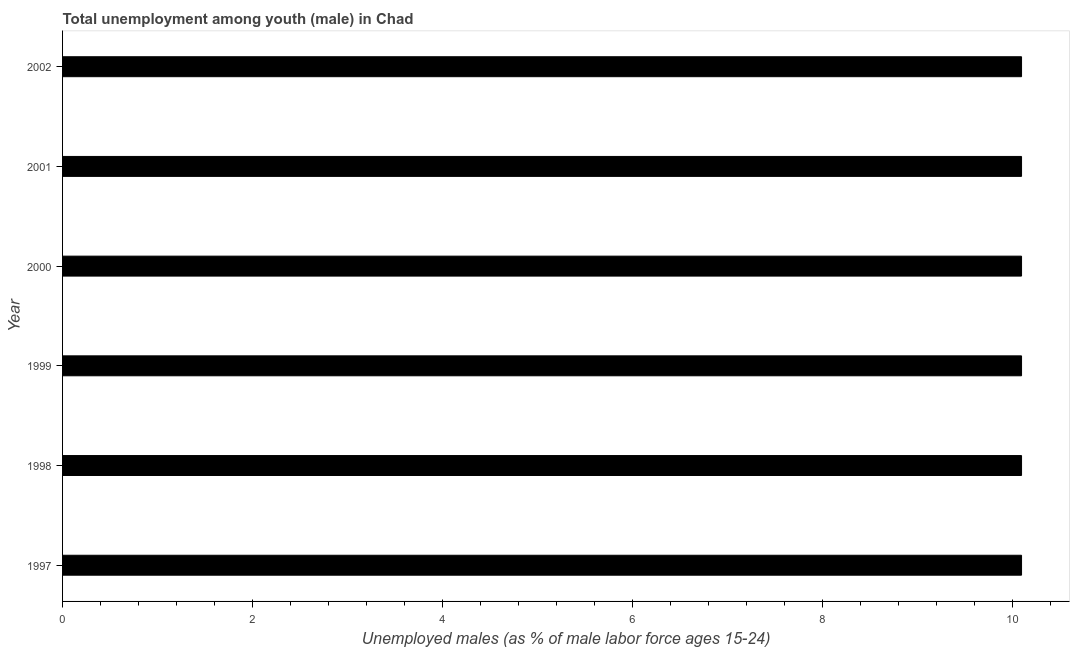Does the graph contain any zero values?
Offer a terse response. No. What is the title of the graph?
Your answer should be very brief. Total unemployment among youth (male) in Chad. What is the label or title of the X-axis?
Give a very brief answer. Unemployed males (as % of male labor force ages 15-24). What is the label or title of the Y-axis?
Keep it short and to the point. Year. What is the unemployed male youth population in 1998?
Keep it short and to the point. 10.1. Across all years, what is the maximum unemployed male youth population?
Provide a short and direct response. 10.1. Across all years, what is the minimum unemployed male youth population?
Your response must be concise. 10.1. In which year was the unemployed male youth population maximum?
Your answer should be compact. 1997. What is the sum of the unemployed male youth population?
Ensure brevity in your answer.  60.6. What is the difference between the unemployed male youth population in 1999 and 2000?
Your response must be concise. 0. What is the average unemployed male youth population per year?
Provide a succinct answer. 10.1. What is the median unemployed male youth population?
Your answer should be compact. 10.1. In how many years, is the unemployed male youth population greater than 9.2 %?
Provide a short and direct response. 6. Do a majority of the years between 2001 and 1997 (inclusive) have unemployed male youth population greater than 4.4 %?
Give a very brief answer. Yes. What is the ratio of the unemployed male youth population in 1998 to that in 1999?
Give a very brief answer. 1. Is the unemployed male youth population in 2001 less than that in 2002?
Your answer should be compact. No. Is the difference between the unemployed male youth population in 1998 and 1999 greater than the difference between any two years?
Offer a very short reply. Yes. Is the sum of the unemployed male youth population in 2000 and 2001 greater than the maximum unemployed male youth population across all years?
Provide a succinct answer. Yes. What is the difference between the highest and the lowest unemployed male youth population?
Provide a short and direct response. 0. In how many years, is the unemployed male youth population greater than the average unemployed male youth population taken over all years?
Ensure brevity in your answer.  0. How many bars are there?
Provide a short and direct response. 6. How many years are there in the graph?
Offer a very short reply. 6. What is the difference between two consecutive major ticks on the X-axis?
Provide a short and direct response. 2. Are the values on the major ticks of X-axis written in scientific E-notation?
Ensure brevity in your answer.  No. What is the Unemployed males (as % of male labor force ages 15-24) in 1997?
Offer a very short reply. 10.1. What is the Unemployed males (as % of male labor force ages 15-24) in 1998?
Make the answer very short. 10.1. What is the Unemployed males (as % of male labor force ages 15-24) in 1999?
Ensure brevity in your answer.  10.1. What is the Unemployed males (as % of male labor force ages 15-24) of 2000?
Give a very brief answer. 10.1. What is the Unemployed males (as % of male labor force ages 15-24) in 2001?
Make the answer very short. 10.1. What is the Unemployed males (as % of male labor force ages 15-24) in 2002?
Keep it short and to the point. 10.1. What is the difference between the Unemployed males (as % of male labor force ages 15-24) in 1997 and 1999?
Ensure brevity in your answer.  0. What is the difference between the Unemployed males (as % of male labor force ages 15-24) in 1997 and 2000?
Make the answer very short. 0. What is the difference between the Unemployed males (as % of male labor force ages 15-24) in 1997 and 2002?
Provide a succinct answer. 0. What is the difference between the Unemployed males (as % of male labor force ages 15-24) in 1998 and 1999?
Your response must be concise. 0. What is the difference between the Unemployed males (as % of male labor force ages 15-24) in 1998 and 2002?
Provide a succinct answer. 0. What is the difference between the Unemployed males (as % of male labor force ages 15-24) in 1999 and 2001?
Give a very brief answer. 0. What is the difference between the Unemployed males (as % of male labor force ages 15-24) in 1999 and 2002?
Ensure brevity in your answer.  0. What is the difference between the Unemployed males (as % of male labor force ages 15-24) in 2000 and 2001?
Your answer should be compact. 0. What is the ratio of the Unemployed males (as % of male labor force ages 15-24) in 1997 to that in 1998?
Make the answer very short. 1. What is the ratio of the Unemployed males (as % of male labor force ages 15-24) in 1997 to that in 1999?
Your answer should be compact. 1. What is the ratio of the Unemployed males (as % of male labor force ages 15-24) in 1997 to that in 2001?
Your answer should be very brief. 1. What is the ratio of the Unemployed males (as % of male labor force ages 15-24) in 1998 to that in 2000?
Offer a very short reply. 1. What is the ratio of the Unemployed males (as % of male labor force ages 15-24) in 1998 to that in 2001?
Keep it short and to the point. 1. What is the ratio of the Unemployed males (as % of male labor force ages 15-24) in 1998 to that in 2002?
Offer a terse response. 1. What is the ratio of the Unemployed males (as % of male labor force ages 15-24) in 1999 to that in 2000?
Ensure brevity in your answer.  1. What is the ratio of the Unemployed males (as % of male labor force ages 15-24) in 1999 to that in 2002?
Provide a short and direct response. 1. What is the ratio of the Unemployed males (as % of male labor force ages 15-24) in 2000 to that in 2002?
Offer a terse response. 1. 